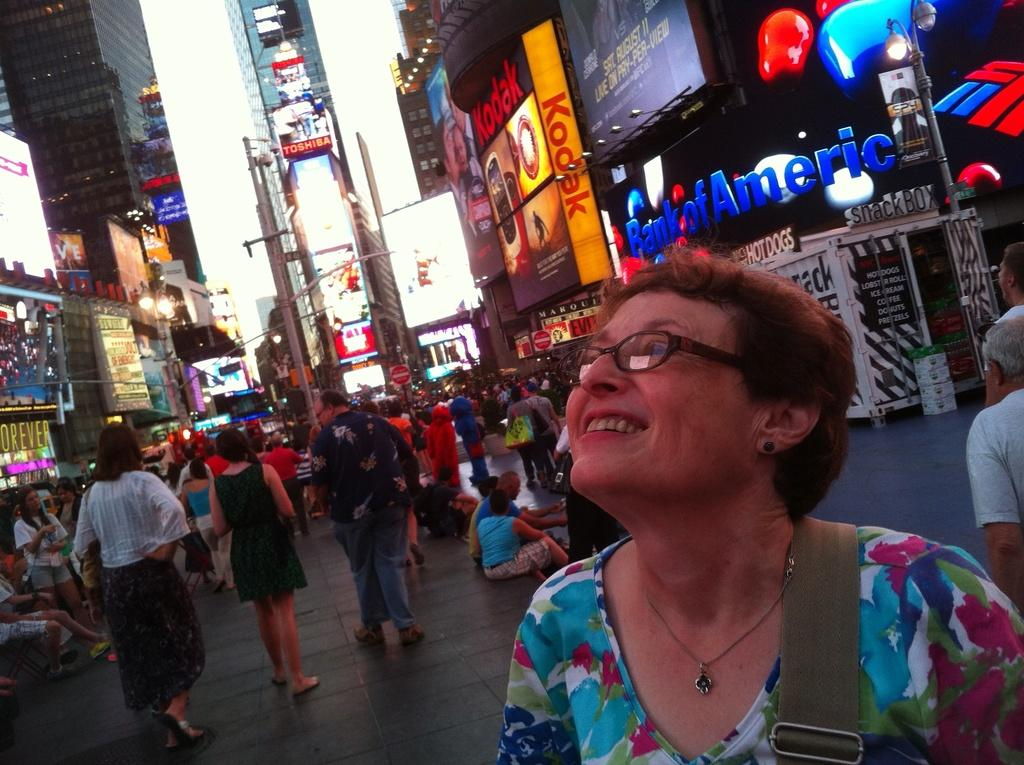What is happening on the roads in the image? There are many people on the roads in the image. What are the people holding? The people are holding bags. What can be seen in the background of the image? There are buildings visible in the image. What type of signs are present in the image? There are boards with text in the image. What can be seen illuminating the scene? There are lights visible in the image. Where is the sofa located in the image? There is no sofa present in the image. What is the value of the cent in the image? There is no mention of a cent or any monetary value in the image. 